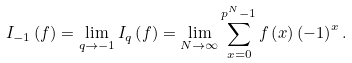<formula> <loc_0><loc_0><loc_500><loc_500>I _ { - 1 } \left ( f \right ) = \lim _ { q \rightarrow - 1 } I _ { q } \left ( f \right ) = \lim _ { N \rightarrow \infty } \sum _ { x = 0 } ^ { p ^ { N } - 1 } f \left ( x \right ) \left ( - 1 \right ) ^ { x } .</formula> 